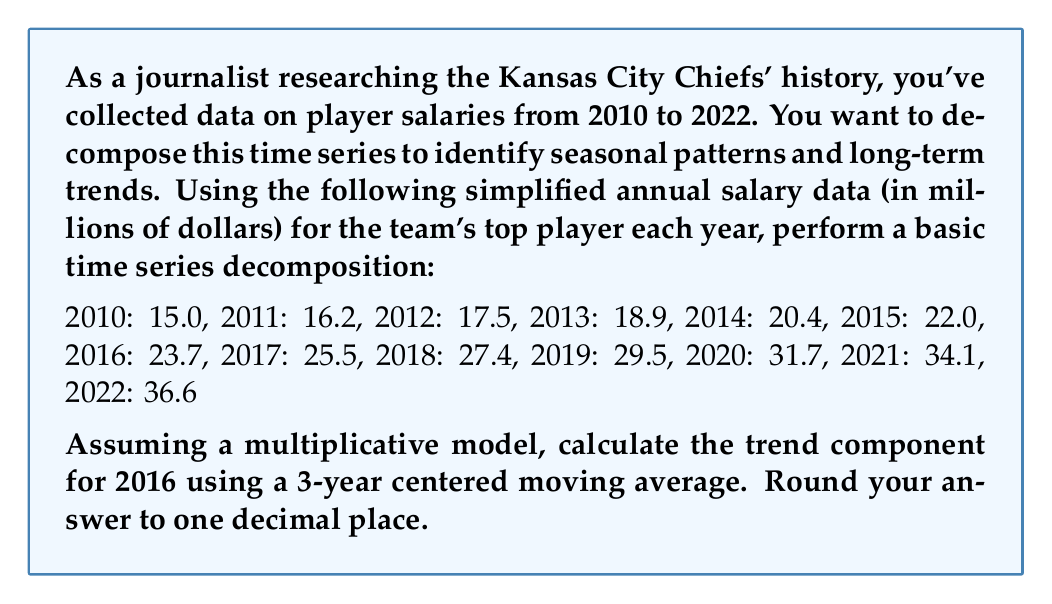Show me your answer to this math problem. To decompose this time series and find the trend component for 2016 using a 3-year centered moving average, we'll follow these steps:

1) First, we need to calculate the 3-year moving averages. For each year, we'll average the values of the current year, the previous year, and the next year.

2) The formula for the 3-year moving average is:

   $$MA_t = \frac{Y_{t-1} + Y_t + Y_{t+1}}{3}$$

   where $MA_t$ is the moving average for year $t$, and $Y_t$ is the observed value for year $t$.

3) Let's calculate the moving averages for 2011 to 2021:

   2011: $\frac{15.0 + 16.2 + 17.5}{3} = 16.2$
   2012: $\frac{16.2 + 17.5 + 18.9}{3} = 17.5$
   2013: $\frac{17.5 + 18.9 + 20.4}{3} = 18.9$
   2014: $\frac{18.9 + 20.4 + 22.0}{3} = 20.4$
   2015: $\frac{20.4 + 22.0 + 23.7}{3} = 22.0$
   2016: $\frac{22.0 + 23.7 + 25.5}{3} = 23.7$
   2017: $\frac{23.7 + 25.5 + 27.4}{3} = 25.5$
   2018: $\frac{25.5 + 27.4 + 29.5}{3} = 27.5$
   2019: $\frac{27.4 + 29.5 + 31.7}{3} = 29.5$
   2020: $\frac{29.5 + 31.7 + 34.1}{3} = 31.8$
   2021: $\frac{31.7 + 34.1 + 36.6}{3} = 34.1$

4) The moving average for 2016 is 23.7, which represents the trend component for that year.

5) Rounding to one decimal place, we get 23.7.
Answer: 23.7 